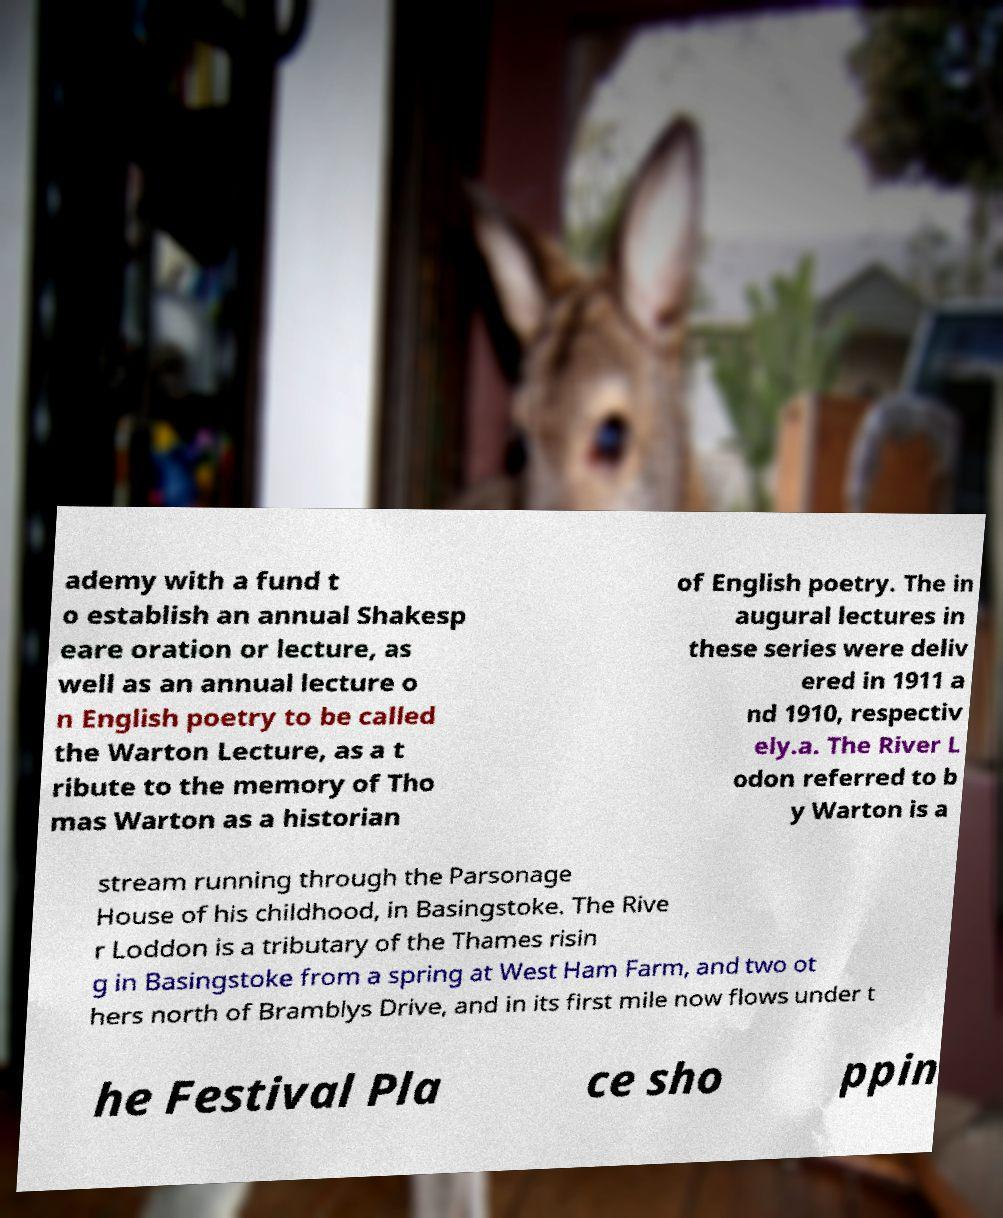For documentation purposes, I need the text within this image transcribed. Could you provide that? ademy with a fund t o establish an annual Shakesp eare oration or lecture, as well as an annual lecture o n English poetry to be called the Warton Lecture, as a t ribute to the memory of Tho mas Warton as a historian of English poetry. The in augural lectures in these series were deliv ered in 1911 a nd 1910, respectiv ely.a. The River L odon referred to b y Warton is a stream running through the Parsonage House of his childhood, in Basingstoke. The Rive r Loddon is a tributary of the Thames risin g in Basingstoke from a spring at West Ham Farm, and two ot hers north of Bramblys Drive, and in its first mile now flows under t he Festival Pla ce sho ppin 